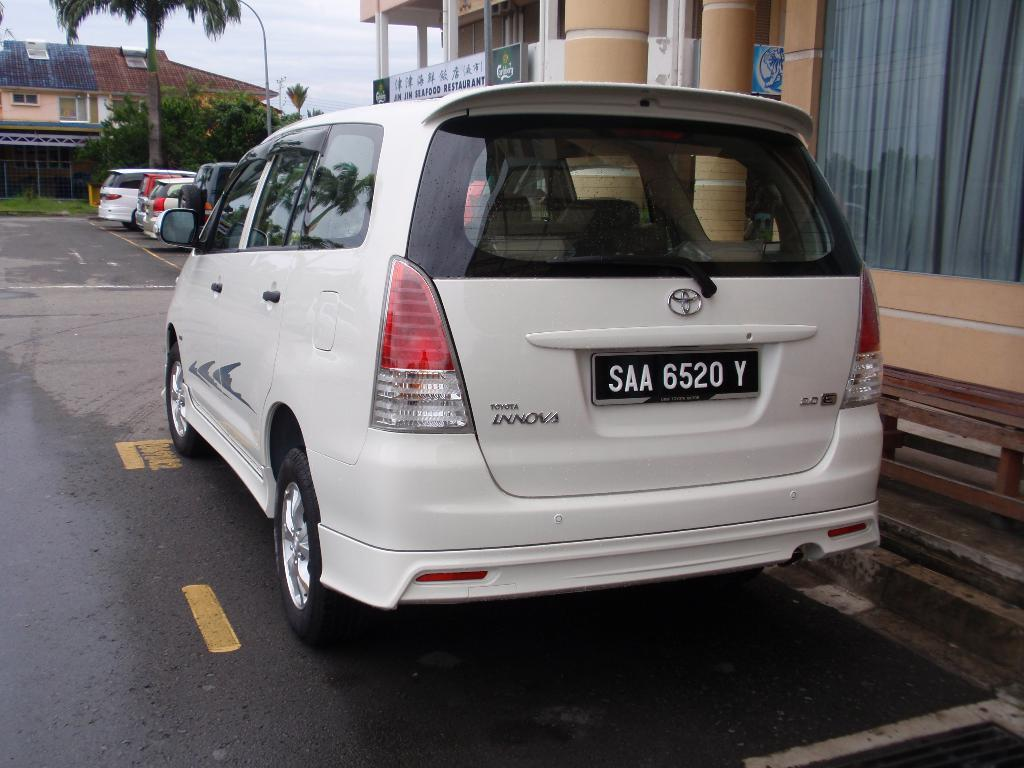<image>
Relay a brief, clear account of the picture shown. A Toyota minivan with a tag that reads SAA 6520 Y. 